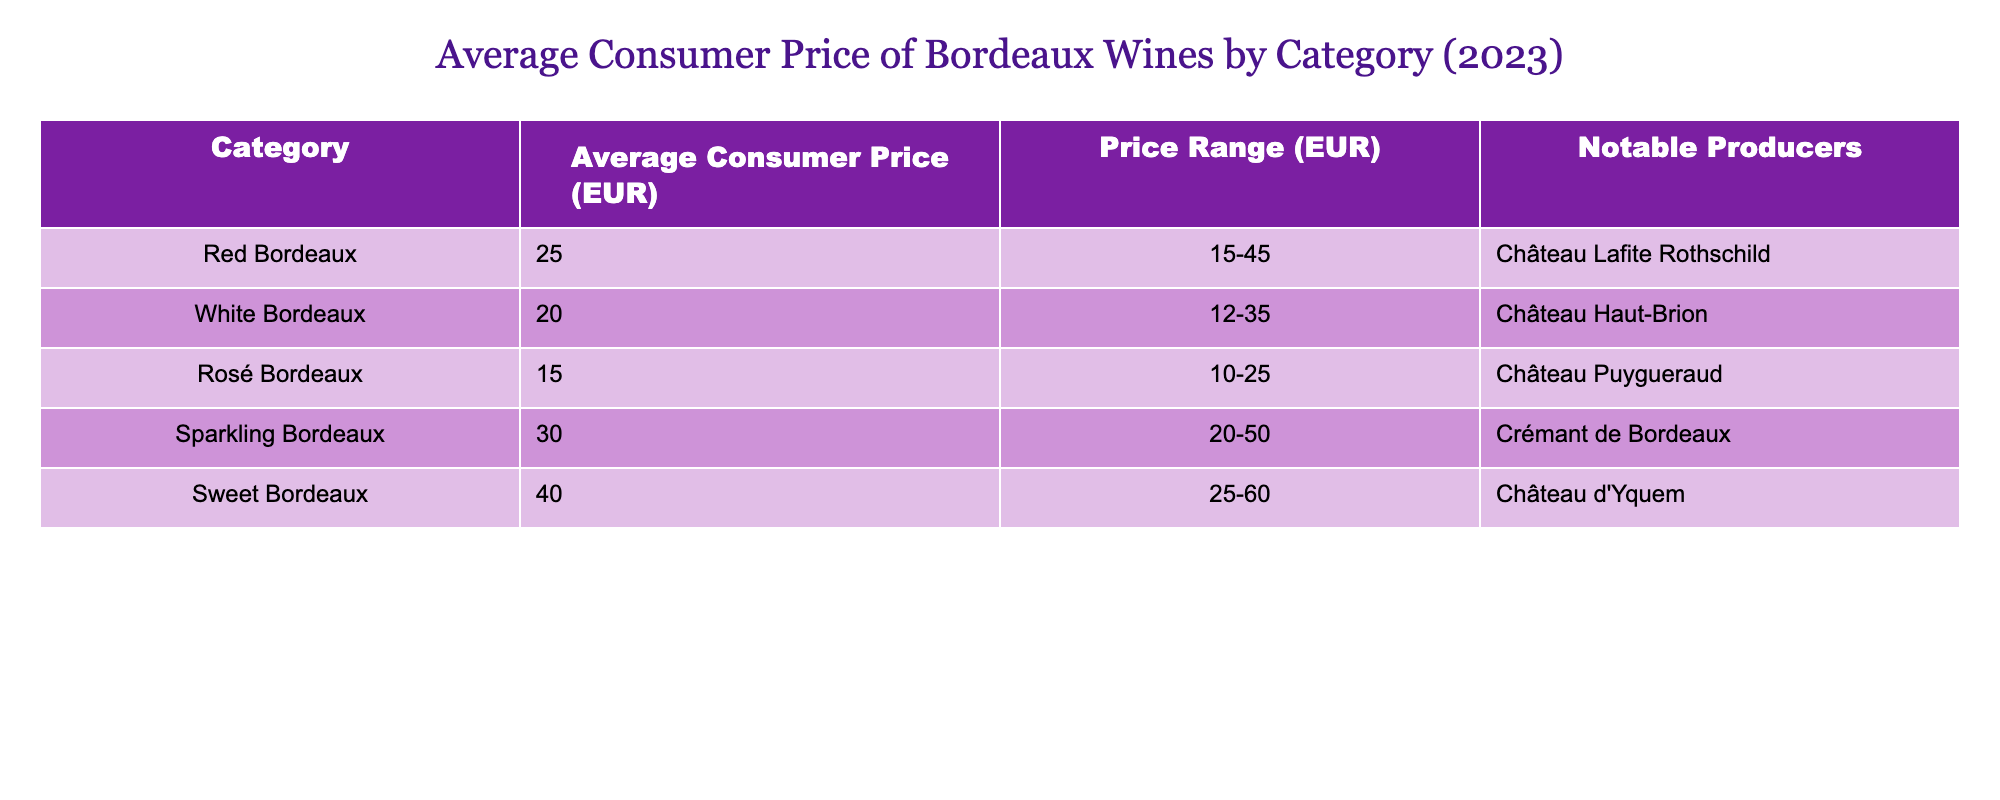What is the average consumer price of Red Bordeaux wines? The table shows the average consumer price for Red Bordeaux wines is listed under the "Average Consumer Price (EUR)" column for the "Red Bordeaux" category, which is 25 EUR.
Answer: 25 EUR What is the price range for Sweet Bordeaux wines? The price range for Sweet Bordeaux wines can be found in the "Price Range (EUR)" column for the "Sweet Bordeaux" category, which is 25-60 EUR.
Answer: 25-60 EUR Is the average price of Sparkling Bordeaux wines higher than that of Red Bordeaux wines? The average price for Sparkling Bordeaux wines is 30 EUR, while for Red Bordeaux wines it is 25 EUR. Since 30 is greater than 25, the average price of Sparkling Bordeaux wines is higher.
Answer: Yes What is the total average consumer price of all Bordeaux wine categories listed in the table? To find the total average consumer price, sum the average prices of all categories: 25 (Red Bordeaux) + 20 (White Bordeaux) + 15 (Rosé Bordeaux) + 30 (Sparkling Bordeaux) + 40 (Sweet Bordeaux) = 130 EUR. Therefore, the total average price is 130 EUR.
Answer: 130 EUR Are there any notable producers listed for Rosé Bordeaux wines? The table mentions notable producers for each wine category. For Rosé Bordeaux, the notable producer listed is Château Puygueraud.
Answer: Yes What is the difference between the average consumer price of Sweet Bordeaux wines and Sparkling Bordeaux wines? The average for Sweet Bordeaux is 40 EUR and for Sparkling Bordeaux is 30 EUR. To find the difference, subtract the average price of Sparkling Bordeaux from that of Sweet Bordeaux: 40 - 30 = 10 EUR.
Answer: 10 EUR Which Bordeaux wine category has the lowest average consumer price? By examining the "Average Consumer Price (EUR)" column, Rosé Bordeaux has the lowest average consumer price at 15 EUR in comparison to the others.
Answer: Rosé Bordeaux Is there a notable producer for White Bordeaux wines mentioned in the table? The table does list a notable producer for White Bordeaux, which is Château Haut-Brion. Therefore, the answer is affirmative.
Answer: Yes 